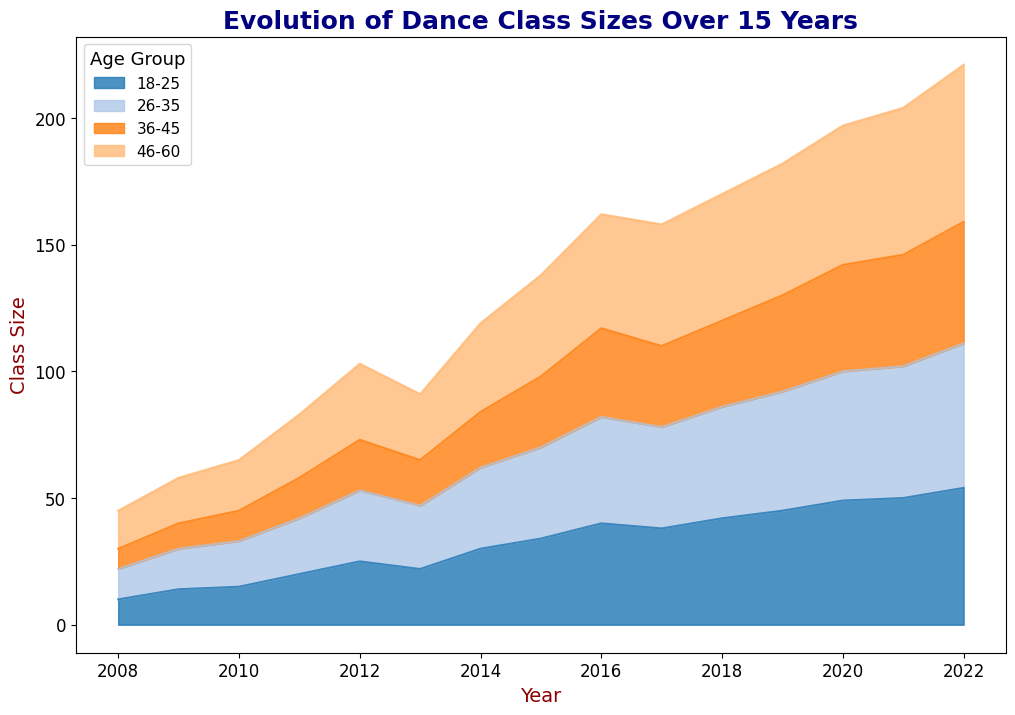What year had the highest overall class size for the age group 46-60? First, locate the color representing the age group 46-60 in the area chart. Then, identify the year with the tallest segment in that color. This peak represents the highest class size for this age group.
Answer: 2022 Which age group showed the most significant increase in class size over the 15 years? Identify the color associated with each age group and examine the area chart for each group's growth from the start to the end of the timeline. Calculate the height difference to determine which group had the largest net increase.
Answer: 18-25 In what year did the class sizes for age groups 18-25 and 26-35 both increase? First, locate the colors for age groups 18-25 and 26-35. Then, scan through the years and find the overlap where both areas have visibly increased in the same year.
Answer: 2016 Comparing 2008 and 2018, by how much did the class size for the age group 36-45 change? Find the height of the segment corresponding to the age group 36-45 in both 2008 and 2018. Subtract the class size in 2008 from the class size in 2018 to find the change.
Answer: 26 What was the overall trend for class sizes in community centers over the 15 years? Examine the cumulative height (total class size) of all age groups each year to observe the overall shape and slope of the stacked area chart. Determine if there's a general upward or downward trend over time.
Answer: Increasing trend Which age group had the smallest class size increase from 2008 to 2022? Identify the colors for each age group. Calculate the difference in the height of each age group's segment from 2008 to 2022, and then compare these differences to find the smallest.
Answer: 26-35 How do the class sizes for age group 46-60 in 2008 and 2022 compare? Locate the heights of the segments for the age group 46-60 in both 2008 and 2022. Directly compare the heights to determine which year had a larger class size.
Answer: 2022 is larger What age group had the most consistent class size over the years? By visually inspecting the area chart, look for the age group whose colored segment remains relatively stable in height across the 15 years without significant fluctuations.
Answer: 36-45 Between 2015 and 2020, which age group saw the fastest growth in class size? Examine each age group’s segment from 2015 to 2020, noting which areas have the most significant increase in height. This visible rapid increase signifies the fastest growth.
Answer: 18-25 In which years were class sizes for the age group 18-25 less than the age group 46-60? Compare the heights of the color segments for age groups 18-25 and 46-60 year by year. List the years where the segment for 18-25 is shorter than 46-60.
Answer: 2008, 2009, 2010, 2011 